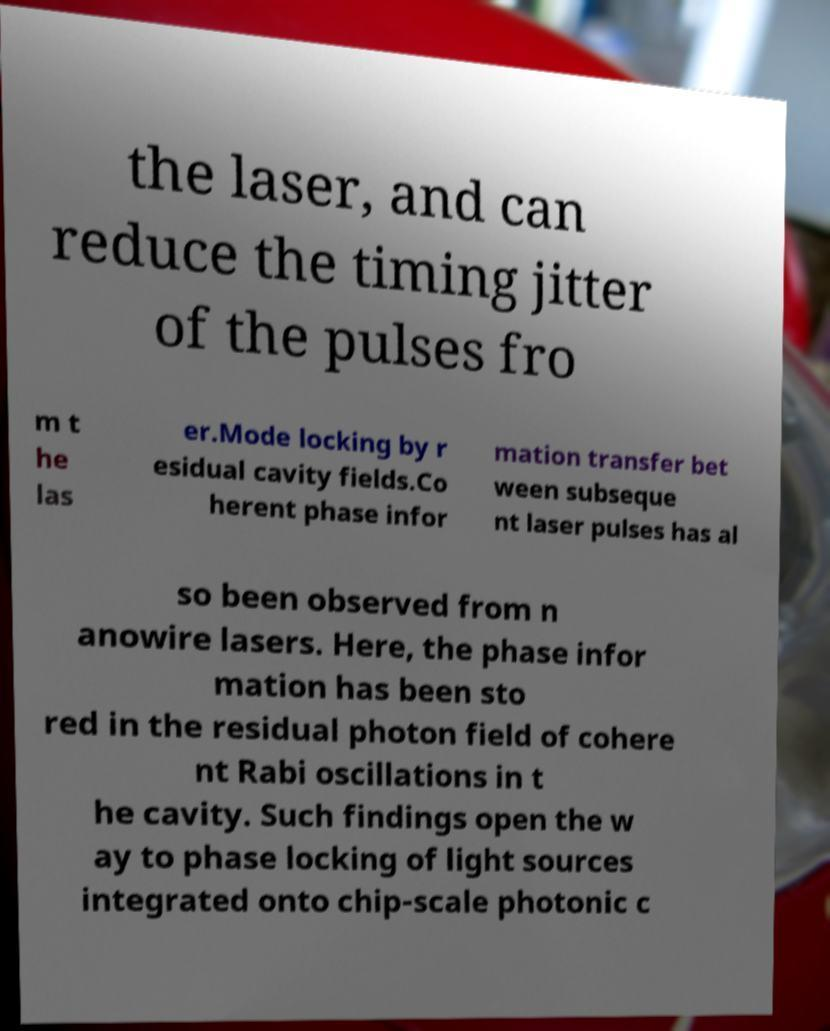Can you accurately transcribe the text from the provided image for me? the laser, and can reduce the timing jitter of the pulses fro m t he las er.Mode locking by r esidual cavity fields.Co herent phase infor mation transfer bet ween subseque nt laser pulses has al so been observed from n anowire lasers. Here, the phase infor mation has been sto red in the residual photon field of cohere nt Rabi oscillations in t he cavity. Such findings open the w ay to phase locking of light sources integrated onto chip-scale photonic c 